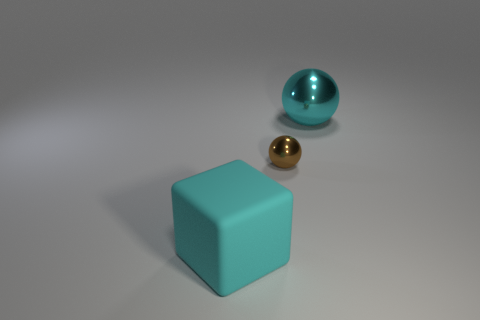There is a matte thing that is the same size as the cyan shiny ball; what is its color? cyan 